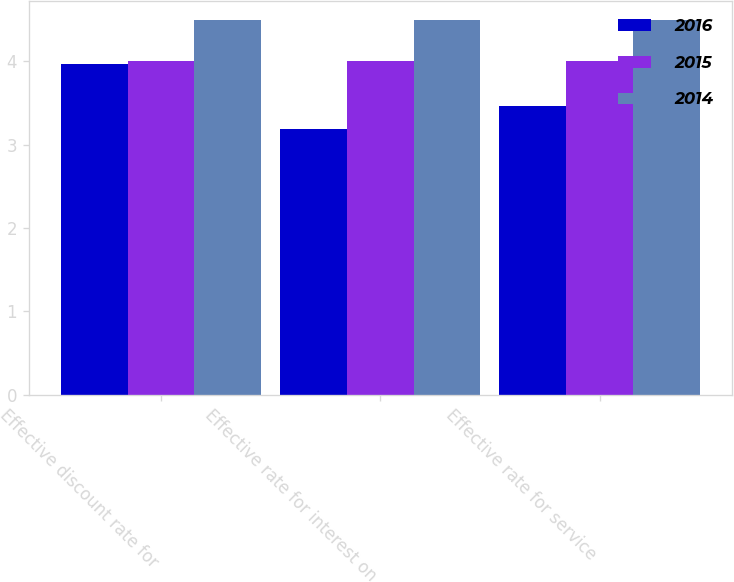Convert chart. <chart><loc_0><loc_0><loc_500><loc_500><stacked_bar_chart><ecel><fcel>Effective discount rate for<fcel>Effective rate for interest on<fcel>Effective rate for service<nl><fcel>2016<fcel>3.97<fcel>3.19<fcel>3.46<nl><fcel>2015<fcel>4<fcel>4<fcel>4<nl><fcel>2014<fcel>4.5<fcel>4.5<fcel>4.5<nl></chart> 